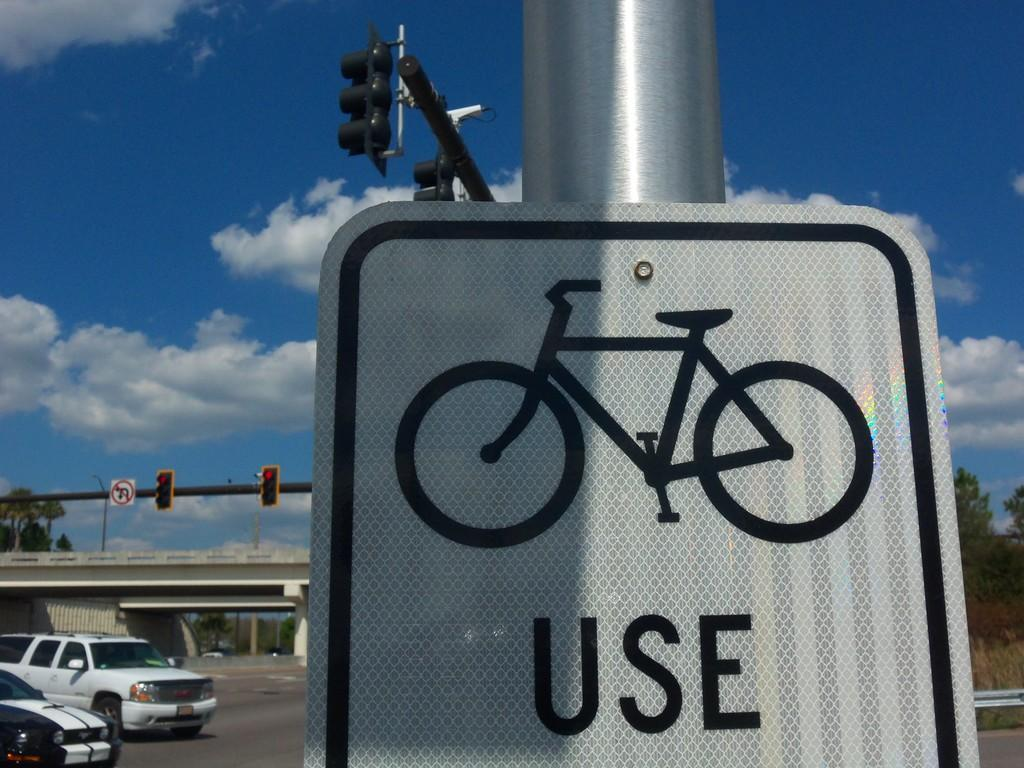<image>
Give a short and clear explanation of the subsequent image. a white sign on a metal post with a bike icon that says use 